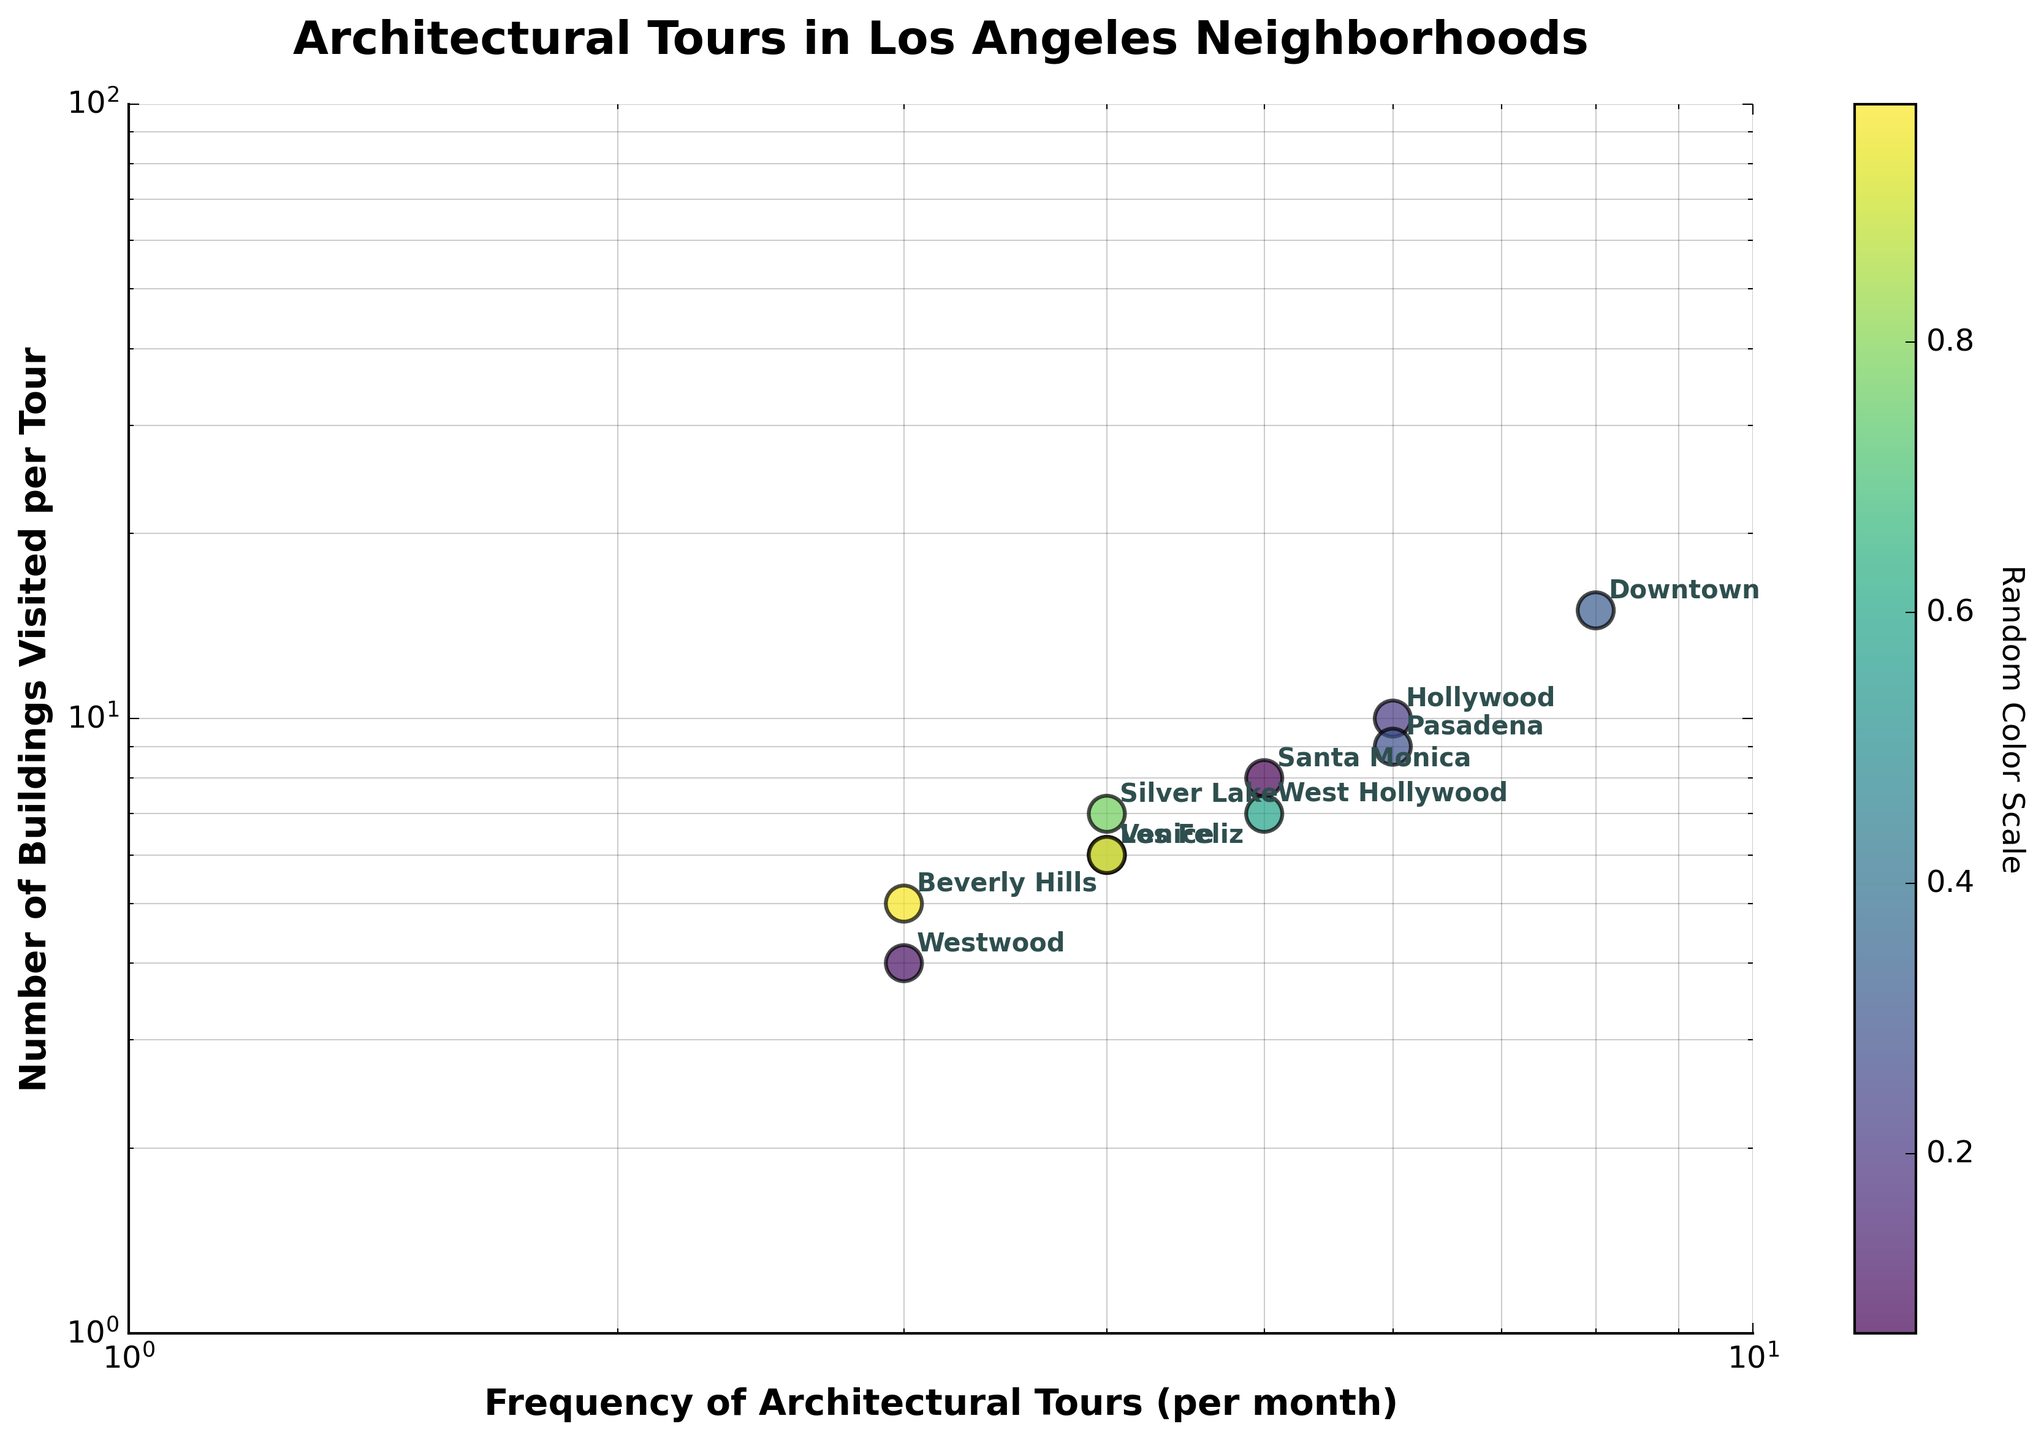What is the title of the scatter plot? The title is often located at the top of the plot and provides a summary of the data being visualized. In this case, the title of the plot is clearly mentioned.
Answer: Architectural Tours in Los Angeles Neighborhoods Which neighborhood has the highest frequency of architectural tours? By looking at the x-axis, identify the data point furthest to the right. The neighborhood corresponding to this point is labeled with an annotation.
Answer: Downtown Which neighborhood has the fewest buildings visited per tour? By examining the y-axis, find the data point lowest on the axis. The neighborhood corresponding to this point is labeled with an annotation.
Answer: Westwood What is the relationship between the frequency of tours and the number of buildings visited in Beverly Hills and Santa Monica? Compare the x and y values of both neighborhoods by locating their respective data points and analyzing their positions. Beverly Hills has 3 monthly tours and visits 5 buildings per tour, while Santa Monica has 5 monthly tours and visits 8 buildings per tour. This shows that Santa Monica has more frequent tours and visits more buildings per tour.
Answer: Santa Monica has more frequent tours and more buildings visited per tour How many neighborhoods have an equal number of buildings visited per tour? Look for multiple data points that align horizontally on the y-axis. In this case, Venice and Los Feliz both visit 6 buildings per tour.
Answer: 2 (Venice and Los Feliz) Which neighborhoods have the same frequency of architectural tours? Identify data points aligned vertically on the x-axis. Here, Silver Lake and Los Feliz both have 4 monthly tours.
Answer: Silver Lake and Los Feliz What is the sum of the frequency of tours for neighborhoods visiting 5 buildings per tour? Identify neighborhoods visiting 5 buildings per tour from the y-axis, then sum their frequencies from the x-axis. Beverly Hills and Westwood visit 5 buildings, with tour frequencies of 3 each. The total frequency is 3 + 3.
Answer: 6 tours per month Are there more neighborhoods with a frequency of tours greater than 5 or less than or equal to 5? Count the data points on the x-axis above 5 and those at or below 5. Downtown, Hollywood, and Pasadena are above 5; Silver Lake, Beverly Hills, Santa Monica, Venice, Westwood, Los Feliz, and West Hollywood are 5 or below. Totals are 3 and 7, respectively.
Answer: More neighborhoods are at or below 5 Which neighborhood has the closest frequency of tours to Silver Lake, and how many more buildings does it visit per tour? Identify the frequency of tours for Silver Lake, then find the closest frequency to it among other points. Silver Lake has 4, and Los Feliz is closest with 4 as well. Compared by y-axis, Los Feliz visits 6 buildings while Silver Lake visits 7, thus Silver Lake visits 1 more building per tour.
Answer: Los Feliz visits 1 fewer building per tour What is the average number of buildings visited per tour for neighborhoods with a tour frequency of 5 or greater? First, identify the neighborhoods with 5 or more tours (Downtown, Hollywood, Santa Monica, Pasadena, West Hollywood), then calculate the average y-value for these points. The values are 15, 10, 8, 9, and 7. The sum is 49; there are 5 data points, so the average is 49/5.
Answer: 9.8 buildings per tour 